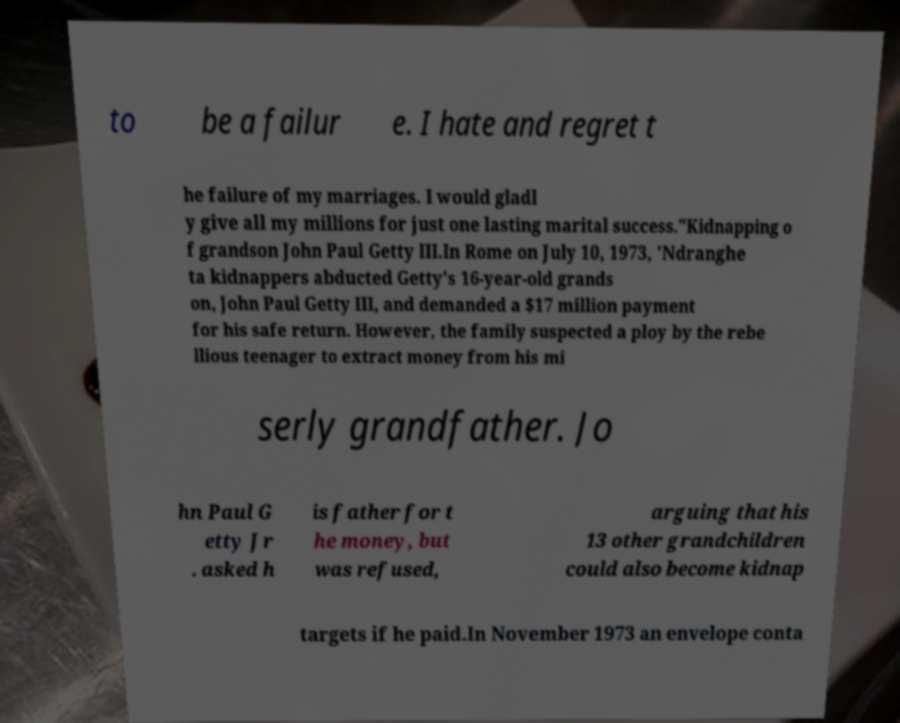Please read and relay the text visible in this image. What does it say? to be a failur e. I hate and regret t he failure of my marriages. I would gladl y give all my millions for just one lasting marital success."Kidnapping o f grandson John Paul Getty III.In Rome on July 10, 1973, 'Ndranghe ta kidnappers abducted Getty's 16-year-old grands on, John Paul Getty III, and demanded a $17 million payment for his safe return. However, the family suspected a ploy by the rebe llious teenager to extract money from his mi serly grandfather. Jo hn Paul G etty Jr . asked h is father for t he money, but was refused, arguing that his 13 other grandchildren could also become kidnap targets if he paid.In November 1973 an envelope conta 